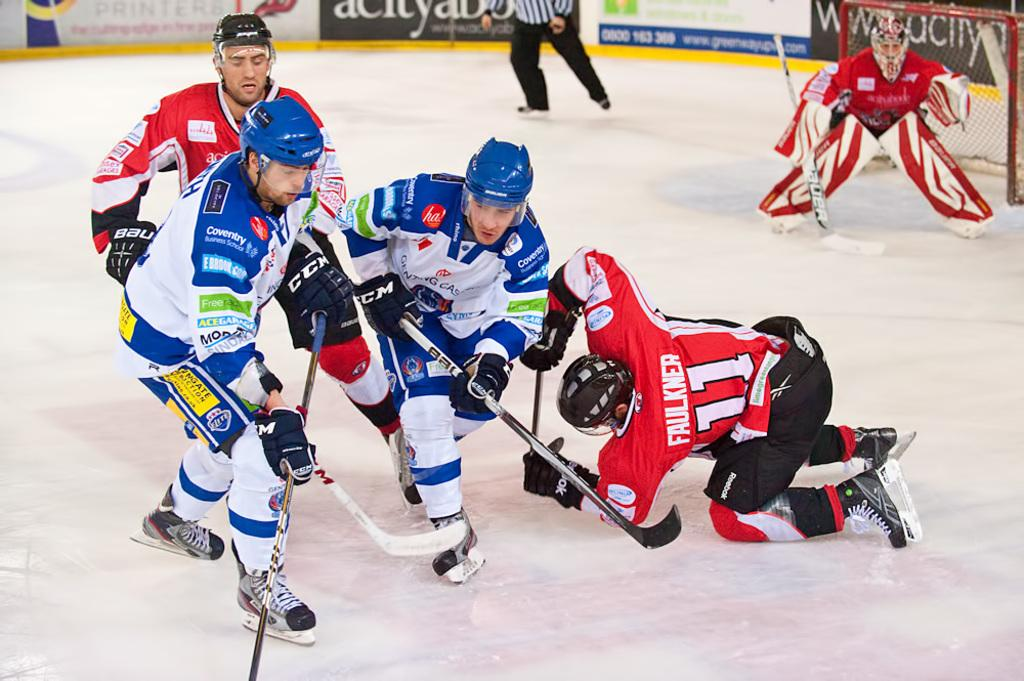<image>
Present a compact description of the photo's key features. Faulkner wearing number 11 makes a defensive play to help his hockey team. 